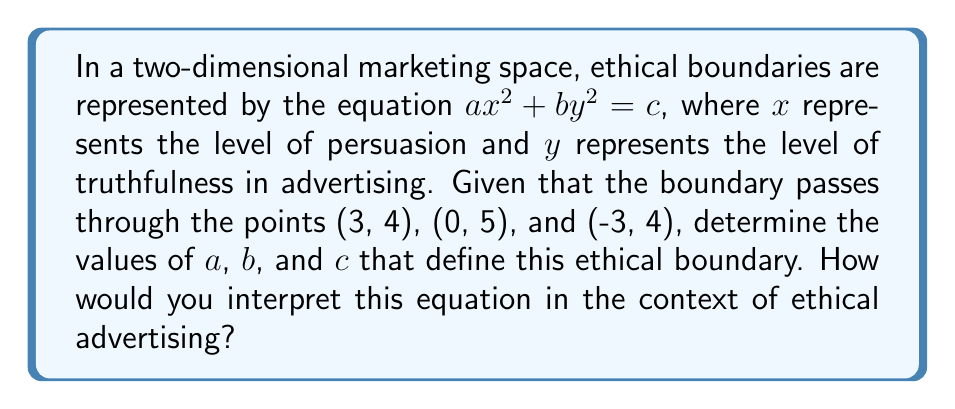Show me your answer to this math problem. Let's approach this step-by-step:

1) We know the general equation is of the form $ax^2 + by^2 = c$. We need to find $a$, $b$, and $c$.

2) We have three points that satisfy this equation:
   (3, 4), (0, 5), and (-3, 4)

3) Let's substitute these points into the equation:
   For (3, 4):  $9a + 16b = c$
   For (0, 5):  $25b = c$
   For (-3, 4): $9a + 16b = c$

4) From the second equation, we can say $c = 25b$

5) Substituting this into the first (or third) equation:
   $9a + 16b = 25b$
   $9a = 9b$
   $a = b$

6) So our equation is of the form $ax^2 + ay^2 = 25a$, or simplified:
   $x^2 + y^2 = 25$

7) We can verify this with our original points:
   For (3, 4):  $3^2 + 4^2 = 9 + 16 = 25$
   For (0, 5):  $0^2 + 5^2 = 0 + 25 = 25$
   For (-3, 4): $(-3)^2 + 4^2 = 9 + 16 = 25$

Interpretation: This equation represents a circle with radius 5 centered at the origin. In the context of ethical advertising:

- The x-axis (persuasion) and y-axis (truthfulness) are equally weighted (same coefficient).
- There's a fixed "ethical budget" (radius of 25) that can be allocated between persuasion and truthfulness.
- As persuasion increases, truthfulness must decrease (and vice versa) to stay on the ethical boundary.
- The circular shape suggests a balanced approach: extreme values in either dimension are discouraged.
Answer: $x^2 + y^2 = 25$ 